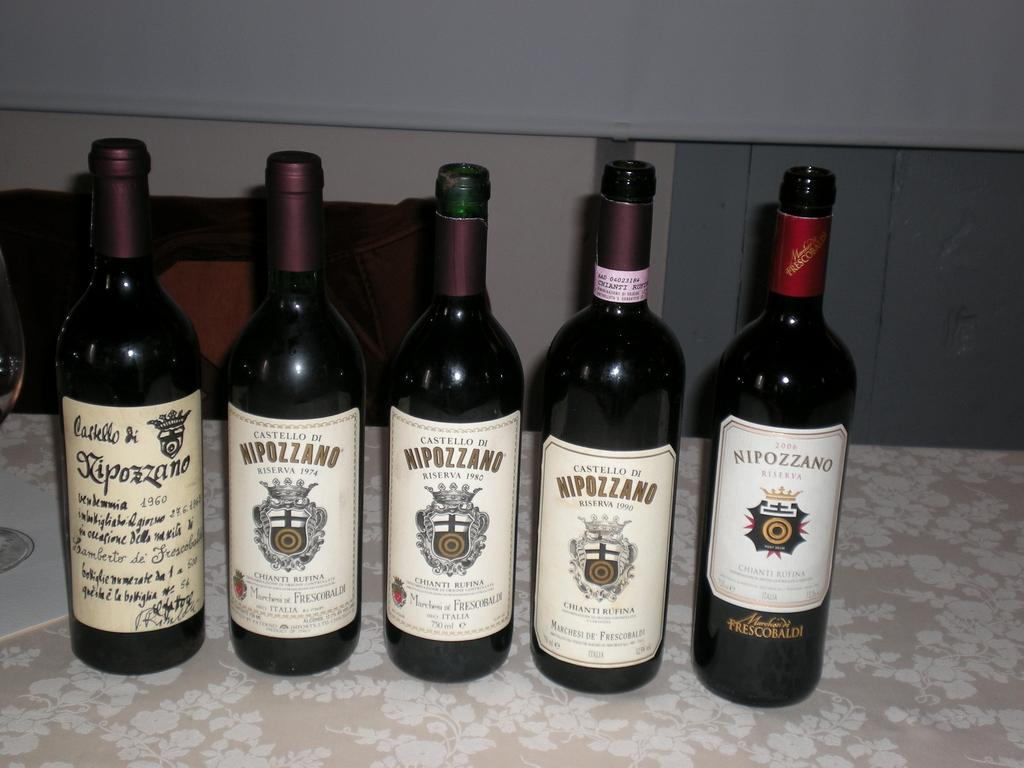<image>
Present a compact description of the photo's key features. Five bottles of wine are labeled with the Nipozzano brand. 